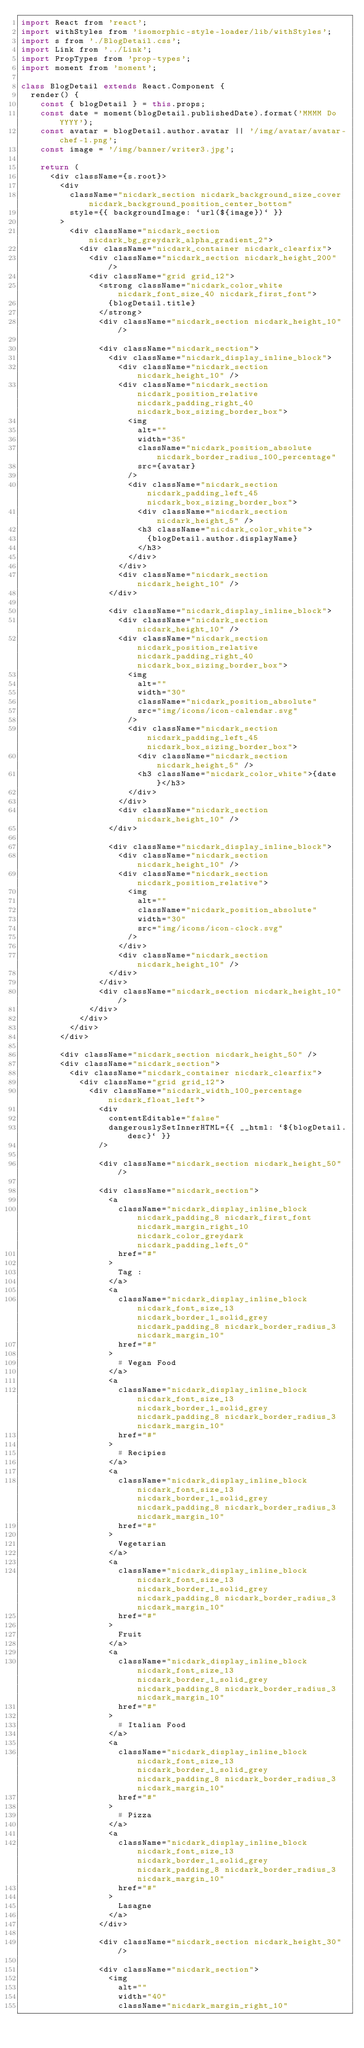Convert code to text. <code><loc_0><loc_0><loc_500><loc_500><_JavaScript_>import React from 'react';
import withStyles from 'isomorphic-style-loader/lib/withStyles';
import s from './BlogDetail.css';
import Link from '../Link';
import PropTypes from 'prop-types';
import moment from 'moment';

class BlogDetail extends React.Component {
  render() {
    const { blogDetail } = this.props;
    const date = moment(blogDetail.publishedDate).format('MMMM Do YYYY');
    const avatar = blogDetail.author.avatar || '/img/avatar/avatar-chef-1.png';
    const image = '/img/banner/writer3.jpg';

    return (
      <div className={s.root}>
        <div
          className="nicdark_section nicdark_background_size_cover nicdark_background_position_center_bottom"
          style={{ backgroundImage: `url(${image})` }}
        >
          <div className="nicdark_section nicdark_bg_greydark_alpha_gradient_2">
            <div className="nicdark_container nicdark_clearfix">
              <div className="nicdark_section nicdark_height_200" />
              <div className="grid grid_12">
                <strong className="nicdark_color_white nicdark_font_size_40 nicdark_first_font">
                  {blogDetail.title}
                </strong>
                <div className="nicdark_section nicdark_height_10" />

                <div className="nicdark_section">
                  <div className="nicdark_display_inline_block">
                    <div className="nicdark_section nicdark_height_10" />
                    <div className="nicdark_section nicdark_position_relative nicdark_padding_right_40 nicdark_box_sizing_border_box">
                      <img
                        alt=""
                        width="35"
                        className="nicdark_position_absolute nicdark_border_radius_100_percentage"
                        src={avatar}
                      />
                      <div className="nicdark_section nicdark_padding_left_45 nicdark_box_sizing_border_box">
                        <div className="nicdark_section nicdark_height_5" />
                        <h3 className="nicdark_color_white">
                          {blogDetail.author.displayName}
                        </h3>
                      </div>
                    </div>
                    <div className="nicdark_section nicdark_height_10" />
                  </div>

                  <div className="nicdark_display_inline_block">
                    <div className="nicdark_section nicdark_height_10" />
                    <div className="nicdark_section nicdark_position_relative nicdark_padding_right_40 nicdark_box_sizing_border_box">
                      <img
                        alt=""
                        width="30"
                        className="nicdark_position_absolute"
                        src="img/icons/icon-calendar.svg"
                      />
                      <div className="nicdark_section nicdark_padding_left_45 nicdark_box_sizing_border_box">
                        <div className="nicdark_section nicdark_height_5" />
                        <h3 className="nicdark_color_white">{date}</h3>
                      </div>
                    </div>
                    <div className="nicdark_section nicdark_height_10" />
                  </div>

                  <div className="nicdark_display_inline_block">
                    <div className="nicdark_section nicdark_height_10" />
                    <div className="nicdark_section nicdark_position_relative">
                      <img
                        alt=""
                        className="nicdark_position_absolute"
                        width="30"
                        src="img/icons/icon-clock.svg"
                      />
                    </div>
                    <div className="nicdark_section nicdark_height_10" />
                  </div>
                </div>
                <div className="nicdark_section nicdark_height_10" />
              </div>
            </div>
          </div>
        </div>

        <div className="nicdark_section nicdark_height_50" />
        <div className="nicdark_section">
          <div className="nicdark_container nicdark_clearfix">
            <div className="grid grid_12">
              <div className="nicdark_width_100_percentage nicdark_float_left">
                <div
                  contentEditable="false"
                  dangerouslySetInnerHTML={{ __html: `${blogDetail.desc}` }}
                />

                <div className="nicdark_section nicdark_height_50" />

                <div className="nicdark_section">
                  <a
                    className="nicdark_display_inline_block nicdark_padding_8 nicdark_first_font nicdark_margin_right_10 nicdark_color_greydark nicdark_padding_left_0"
                    href="#"
                  >
                    Tag :
                  </a>
                  <a
                    className="nicdark_display_inline_block nicdark_font_size_13 nicdark_border_1_solid_grey nicdark_padding_8 nicdark_border_radius_3 nicdark_margin_10"
                    href="#"
                  >
                    # Vegan Food
                  </a>
                  <a
                    className="nicdark_display_inline_block nicdark_font_size_13 nicdark_border_1_solid_grey nicdark_padding_8 nicdark_border_radius_3 nicdark_margin_10"
                    href="#"
                  >
                    # Recipies
                  </a>
                  <a
                    className="nicdark_display_inline_block nicdark_font_size_13 nicdark_border_1_solid_grey nicdark_padding_8 nicdark_border_radius_3 nicdark_margin_10"
                    href="#"
                  >
                    Vegetarian
                  </a>
                  <a
                    className="nicdark_display_inline_block nicdark_font_size_13 nicdark_border_1_solid_grey nicdark_padding_8 nicdark_border_radius_3 nicdark_margin_10"
                    href="#"
                  >
                    Fruit
                  </a>
                  <a
                    className="nicdark_display_inline_block nicdark_font_size_13 nicdark_border_1_solid_grey nicdark_padding_8 nicdark_border_radius_3 nicdark_margin_10"
                    href="#"
                  >
                    # Italian Food
                  </a>
                  <a
                    className="nicdark_display_inline_block nicdark_font_size_13 nicdark_border_1_solid_grey nicdark_padding_8 nicdark_border_radius_3 nicdark_margin_10"
                    href="#"
                  >
                    # Pizza
                  </a>
                  <a
                    className="nicdark_display_inline_block nicdark_font_size_13 nicdark_border_1_solid_grey nicdark_padding_8 nicdark_border_radius_3 nicdark_margin_10"
                    href="#"
                  >
                    Lasagne
                  </a>
                </div>

                <div className="nicdark_section nicdark_height_30" />

                <div className="nicdark_section">
                  <img
                    alt=""
                    width="40"
                    className="nicdark_margin_right_10"</code> 